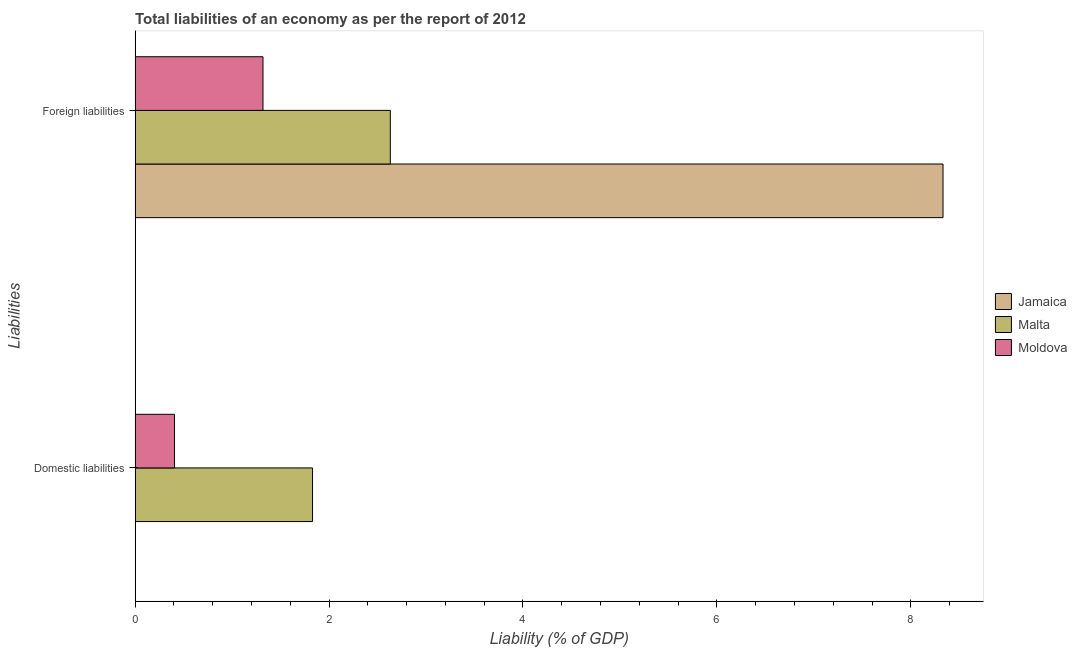How many groups of bars are there?
Offer a very short reply. 2. Are the number of bars per tick equal to the number of legend labels?
Your response must be concise. No. How many bars are there on the 1st tick from the bottom?
Keep it short and to the point. 2. What is the label of the 1st group of bars from the top?
Offer a terse response. Foreign liabilities. What is the incurrence of foreign liabilities in Moldova?
Provide a short and direct response. 1.32. Across all countries, what is the maximum incurrence of foreign liabilities?
Make the answer very short. 8.33. Across all countries, what is the minimum incurrence of foreign liabilities?
Provide a short and direct response. 1.32. In which country was the incurrence of foreign liabilities maximum?
Provide a short and direct response. Jamaica. What is the total incurrence of domestic liabilities in the graph?
Provide a short and direct response. 2.24. What is the difference between the incurrence of foreign liabilities in Malta and that in Moldova?
Offer a very short reply. 1.31. What is the difference between the incurrence of foreign liabilities in Moldova and the incurrence of domestic liabilities in Malta?
Offer a terse response. -0.51. What is the average incurrence of foreign liabilities per country?
Make the answer very short. 4.09. What is the difference between the incurrence of foreign liabilities and incurrence of domestic liabilities in Malta?
Keep it short and to the point. 0.8. In how many countries, is the incurrence of domestic liabilities greater than 5.2 %?
Offer a terse response. 0. What is the ratio of the incurrence of foreign liabilities in Moldova to that in Malta?
Keep it short and to the point. 0.5. In how many countries, is the incurrence of domestic liabilities greater than the average incurrence of domestic liabilities taken over all countries?
Your response must be concise. 1. How many bars are there?
Ensure brevity in your answer.  5. How many countries are there in the graph?
Your answer should be very brief. 3. Are the values on the major ticks of X-axis written in scientific E-notation?
Offer a very short reply. No. Does the graph contain any zero values?
Make the answer very short. Yes. Where does the legend appear in the graph?
Offer a terse response. Center right. How many legend labels are there?
Make the answer very short. 3. How are the legend labels stacked?
Ensure brevity in your answer.  Vertical. What is the title of the graph?
Give a very brief answer. Total liabilities of an economy as per the report of 2012. Does "Chad" appear as one of the legend labels in the graph?
Give a very brief answer. No. What is the label or title of the X-axis?
Offer a very short reply. Liability (% of GDP). What is the label or title of the Y-axis?
Offer a very short reply. Liabilities. What is the Liability (% of GDP) in Malta in Domestic liabilities?
Your response must be concise. 1.83. What is the Liability (% of GDP) in Moldova in Domestic liabilities?
Give a very brief answer. 0.41. What is the Liability (% of GDP) in Jamaica in Foreign liabilities?
Offer a terse response. 8.33. What is the Liability (% of GDP) in Malta in Foreign liabilities?
Keep it short and to the point. 2.63. What is the Liability (% of GDP) of Moldova in Foreign liabilities?
Offer a terse response. 1.32. Across all Liabilities, what is the maximum Liability (% of GDP) of Jamaica?
Ensure brevity in your answer.  8.33. Across all Liabilities, what is the maximum Liability (% of GDP) of Malta?
Ensure brevity in your answer.  2.63. Across all Liabilities, what is the maximum Liability (% of GDP) of Moldova?
Provide a short and direct response. 1.32. Across all Liabilities, what is the minimum Liability (% of GDP) of Malta?
Offer a very short reply. 1.83. Across all Liabilities, what is the minimum Liability (% of GDP) in Moldova?
Ensure brevity in your answer.  0.41. What is the total Liability (% of GDP) in Jamaica in the graph?
Offer a very short reply. 8.33. What is the total Liability (% of GDP) of Malta in the graph?
Keep it short and to the point. 4.46. What is the total Liability (% of GDP) of Moldova in the graph?
Provide a short and direct response. 1.73. What is the difference between the Liability (% of GDP) of Malta in Domestic liabilities and that in Foreign liabilities?
Provide a short and direct response. -0.8. What is the difference between the Liability (% of GDP) in Moldova in Domestic liabilities and that in Foreign liabilities?
Your answer should be very brief. -0.91. What is the difference between the Liability (% of GDP) of Malta in Domestic liabilities and the Liability (% of GDP) of Moldova in Foreign liabilities?
Provide a short and direct response. 0.51. What is the average Liability (% of GDP) in Jamaica per Liabilities?
Make the answer very short. 4.17. What is the average Liability (% of GDP) in Malta per Liabilities?
Give a very brief answer. 2.23. What is the average Liability (% of GDP) of Moldova per Liabilities?
Give a very brief answer. 0.86. What is the difference between the Liability (% of GDP) of Malta and Liability (% of GDP) of Moldova in Domestic liabilities?
Provide a succinct answer. 1.42. What is the difference between the Liability (% of GDP) of Jamaica and Liability (% of GDP) of Malta in Foreign liabilities?
Your response must be concise. 5.7. What is the difference between the Liability (% of GDP) in Jamaica and Liability (% of GDP) in Moldova in Foreign liabilities?
Keep it short and to the point. 7.01. What is the difference between the Liability (% of GDP) in Malta and Liability (% of GDP) in Moldova in Foreign liabilities?
Make the answer very short. 1.31. What is the ratio of the Liability (% of GDP) in Malta in Domestic liabilities to that in Foreign liabilities?
Offer a very short reply. 0.7. What is the ratio of the Liability (% of GDP) of Moldova in Domestic liabilities to that in Foreign liabilities?
Provide a short and direct response. 0.31. What is the difference between the highest and the second highest Liability (% of GDP) in Malta?
Offer a very short reply. 0.8. What is the difference between the highest and the second highest Liability (% of GDP) of Moldova?
Ensure brevity in your answer.  0.91. What is the difference between the highest and the lowest Liability (% of GDP) of Jamaica?
Provide a succinct answer. 8.33. What is the difference between the highest and the lowest Liability (% of GDP) in Malta?
Keep it short and to the point. 0.8. What is the difference between the highest and the lowest Liability (% of GDP) in Moldova?
Your answer should be very brief. 0.91. 